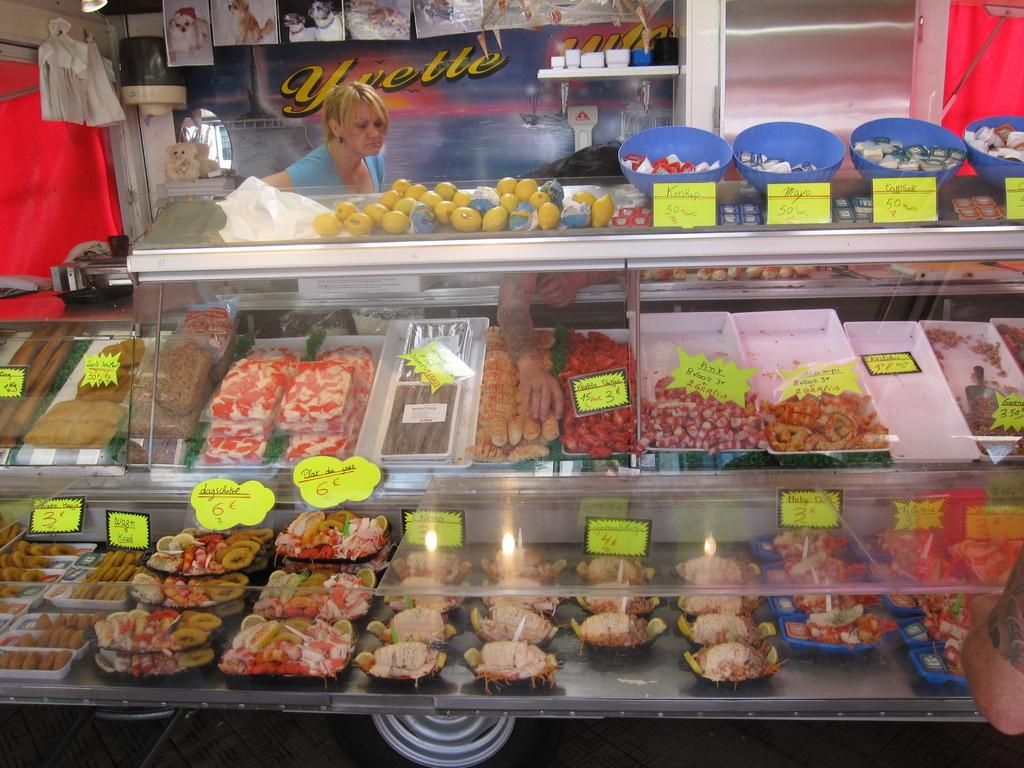<image>
Offer a succinct explanation of the picture presented. A large deli case is in front of a sign with Yvette written on it. 